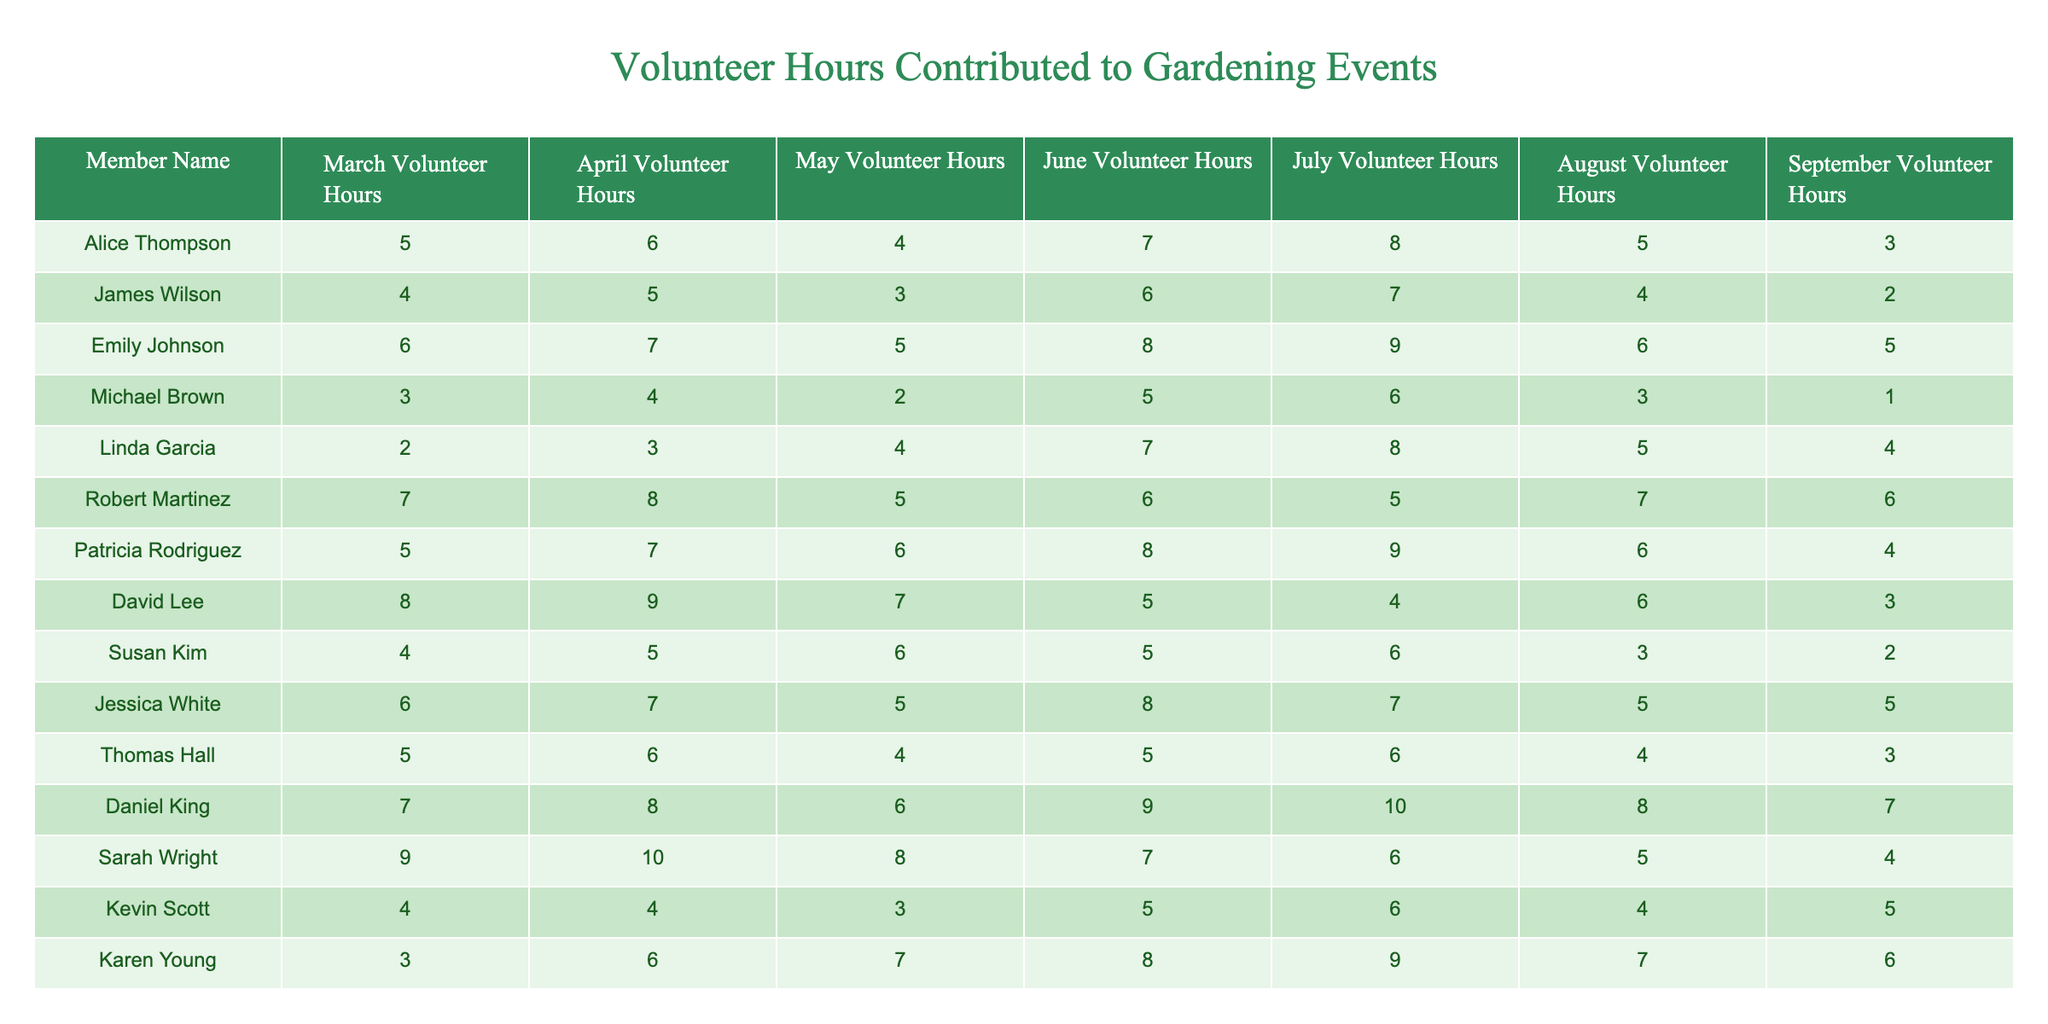What is the total volunteer hours contributed by Emily Johnson in July and August? For Emily Johnson, July volunteer hours are 9 and August volunteer hours are 6. Adding these gives a total of 9 + 6 = 15 hours.
Answer: 15 Who contributed the least volunteer hours in September? I compare the September volunteer hours of all members. Michael Brown contributed 1 hour, which is less than any other member's contributions.
Answer: Michael Brown What is the average number of volunteer hours contributed by Daniel King across all months? Daniel King's hours are: 7 (March), 8 (April), 6 (May), 9 (June), 10 (July), 8 (August), and 7 (September). Summing these gives 7 + 8 + 6 + 9 + 10 + 8 + 7 = 55, and dividing by 7 months gives an average of 55/7 = 7.857, which rounds to 7.86.
Answer: 7.86 Did Susan Kim contribute more than 20 hours in total across all months? I first sum Susan Kim's volunteer hours: 4 (March) + 5 (April) + 6 (May) + 5 (June) + 6 (July) + 3 (August) + 2 (September) = 31 hours. Since 31 is greater than 20, the answer is yes.
Answer: Yes Which member has the highest total volunteer hours, and what is that total? I compute the total for each member. For example, Robert Martinez has 38 hours, and Emily Johnson has 45 hours. After checking all members, Emily Johnson has the highest total.
Answer: Emily Johnson, 45 How many members contributed over 30 volunteer hours in total? I calculate totals for each member: Alice Thompson (43), James Wilson (36), Emily Johnson (45), Robert Martinez (38), Patricia Rodriguez (45), David Lee (42), Jessica White (43), Daniel King (55), and Sarah Wright (49) all exceed 30. The members above 30 are 9 in total.
Answer: 9 What was the highest number of volunteer hours recorded in July? I examine July's hours: Alice (8), James (7), Emily (9), etc. The highest recorded is Emily Johnson with 9 hours.
Answer: 9 Which two members had the most comparable volunteer hours in August? The hour contributions in August are: Robert Martinez (7), Patricia Rodriguez (6), Daniel King (8), and Karen Young (7). The closest pairs with similar numbers are Robert Martinez and Karen Young, both having 7 hours.
Answer: Robert Martinez and Karen Young What is the difference between the highest and lowest total volunteer hours contributed among members? The highest total is 55 (Daniel King), and the lowest is 21 (Michael Brown). The difference is calculated as 55 - 21 = 34.
Answer: 34 